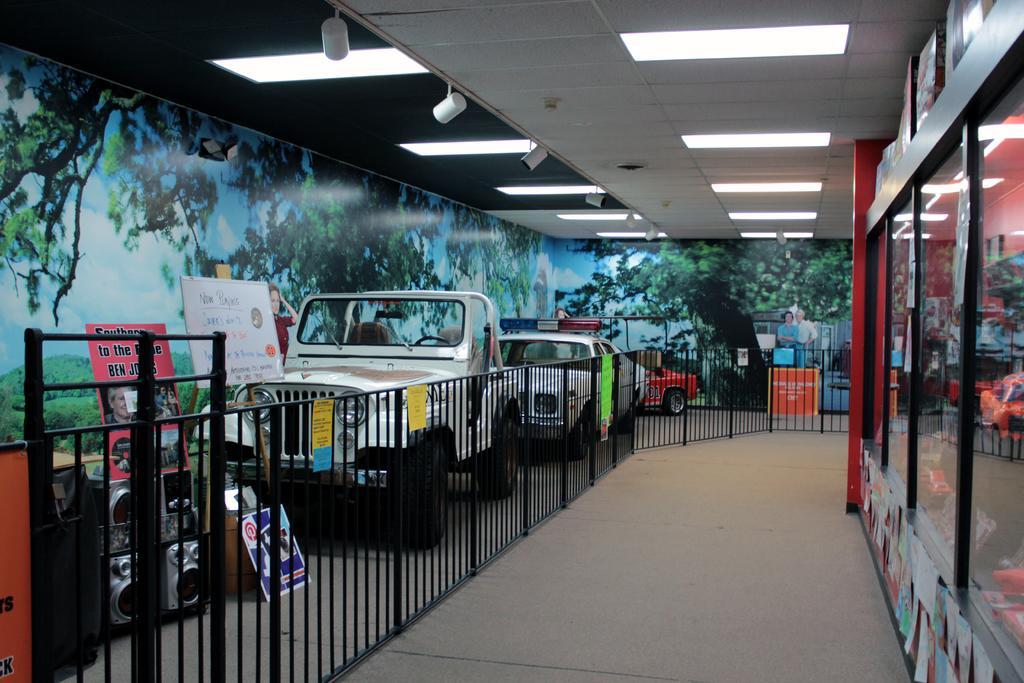Can you describe this image briefly? In this picture I can see there are a few vehicles parked at left side and there is a railing and there are few speakers placed at the left side and there is a poster pasted at the wall and there are trees and mountains in the picture. There is a red color glass wall at right side and there are few papers pasted on the wall. 